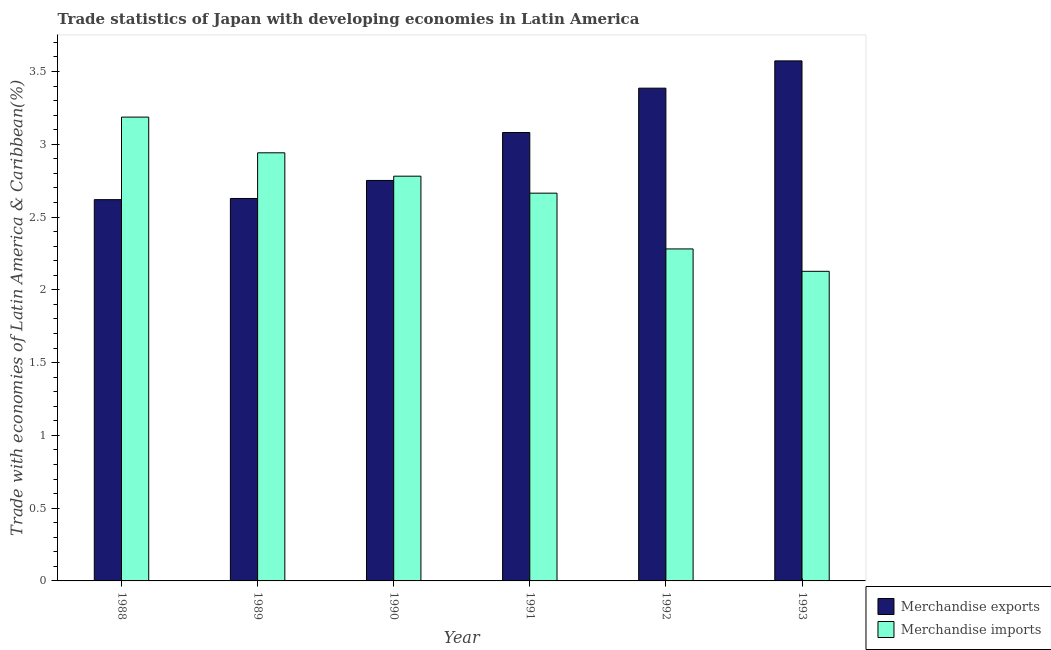How many different coloured bars are there?
Provide a succinct answer. 2. Are the number of bars on each tick of the X-axis equal?
Ensure brevity in your answer.  Yes. How many bars are there on the 2nd tick from the left?
Provide a succinct answer. 2. How many bars are there on the 4th tick from the right?
Offer a very short reply. 2. In how many cases, is the number of bars for a given year not equal to the number of legend labels?
Your answer should be compact. 0. What is the merchandise imports in 1989?
Provide a short and direct response. 2.94. Across all years, what is the maximum merchandise imports?
Keep it short and to the point. 3.19. Across all years, what is the minimum merchandise exports?
Your answer should be very brief. 2.62. In which year was the merchandise exports maximum?
Your response must be concise. 1993. What is the total merchandise imports in the graph?
Provide a short and direct response. 15.98. What is the difference between the merchandise exports in 1990 and that in 1993?
Your answer should be very brief. -0.82. What is the difference between the merchandise exports in 1990 and the merchandise imports in 1991?
Give a very brief answer. -0.33. What is the average merchandise imports per year?
Your answer should be compact. 2.66. In how many years, is the merchandise exports greater than 3.3 %?
Your answer should be compact. 2. What is the ratio of the merchandise exports in 1991 to that in 1993?
Your answer should be very brief. 0.86. Is the merchandise imports in 1990 less than that in 1992?
Make the answer very short. No. Is the difference between the merchandise exports in 1992 and 1993 greater than the difference between the merchandise imports in 1992 and 1993?
Keep it short and to the point. No. What is the difference between the highest and the second highest merchandise exports?
Your answer should be very brief. 0.19. What is the difference between the highest and the lowest merchandise imports?
Offer a terse response. 1.06. In how many years, is the merchandise imports greater than the average merchandise imports taken over all years?
Offer a very short reply. 4. What does the 1st bar from the left in 1992 represents?
Offer a very short reply. Merchandise exports. What does the 2nd bar from the right in 1988 represents?
Make the answer very short. Merchandise exports. How many years are there in the graph?
Make the answer very short. 6. What is the difference between two consecutive major ticks on the Y-axis?
Your answer should be compact. 0.5. Are the values on the major ticks of Y-axis written in scientific E-notation?
Ensure brevity in your answer.  No. Does the graph contain any zero values?
Your response must be concise. No. Where does the legend appear in the graph?
Your answer should be compact. Bottom right. What is the title of the graph?
Provide a short and direct response. Trade statistics of Japan with developing economies in Latin America. What is the label or title of the X-axis?
Provide a short and direct response. Year. What is the label or title of the Y-axis?
Your response must be concise. Trade with economies of Latin America & Caribbean(%). What is the Trade with economies of Latin America & Caribbean(%) in Merchandise exports in 1988?
Offer a terse response. 2.62. What is the Trade with economies of Latin America & Caribbean(%) in Merchandise imports in 1988?
Offer a very short reply. 3.19. What is the Trade with economies of Latin America & Caribbean(%) in Merchandise exports in 1989?
Keep it short and to the point. 2.63. What is the Trade with economies of Latin America & Caribbean(%) of Merchandise imports in 1989?
Your answer should be very brief. 2.94. What is the Trade with economies of Latin America & Caribbean(%) of Merchandise exports in 1990?
Your response must be concise. 2.75. What is the Trade with economies of Latin America & Caribbean(%) of Merchandise imports in 1990?
Offer a very short reply. 2.78. What is the Trade with economies of Latin America & Caribbean(%) in Merchandise exports in 1991?
Give a very brief answer. 3.08. What is the Trade with economies of Latin America & Caribbean(%) in Merchandise imports in 1991?
Provide a succinct answer. 2.66. What is the Trade with economies of Latin America & Caribbean(%) in Merchandise exports in 1992?
Make the answer very short. 3.39. What is the Trade with economies of Latin America & Caribbean(%) of Merchandise imports in 1992?
Your answer should be compact. 2.28. What is the Trade with economies of Latin America & Caribbean(%) in Merchandise exports in 1993?
Offer a very short reply. 3.57. What is the Trade with economies of Latin America & Caribbean(%) in Merchandise imports in 1993?
Give a very brief answer. 2.13. Across all years, what is the maximum Trade with economies of Latin America & Caribbean(%) of Merchandise exports?
Provide a short and direct response. 3.57. Across all years, what is the maximum Trade with economies of Latin America & Caribbean(%) in Merchandise imports?
Make the answer very short. 3.19. Across all years, what is the minimum Trade with economies of Latin America & Caribbean(%) of Merchandise exports?
Your response must be concise. 2.62. Across all years, what is the minimum Trade with economies of Latin America & Caribbean(%) in Merchandise imports?
Ensure brevity in your answer.  2.13. What is the total Trade with economies of Latin America & Caribbean(%) of Merchandise exports in the graph?
Offer a very short reply. 18.04. What is the total Trade with economies of Latin America & Caribbean(%) of Merchandise imports in the graph?
Ensure brevity in your answer.  15.98. What is the difference between the Trade with economies of Latin America & Caribbean(%) in Merchandise exports in 1988 and that in 1989?
Provide a short and direct response. -0.01. What is the difference between the Trade with economies of Latin America & Caribbean(%) in Merchandise imports in 1988 and that in 1989?
Provide a short and direct response. 0.25. What is the difference between the Trade with economies of Latin America & Caribbean(%) in Merchandise exports in 1988 and that in 1990?
Give a very brief answer. -0.13. What is the difference between the Trade with economies of Latin America & Caribbean(%) of Merchandise imports in 1988 and that in 1990?
Make the answer very short. 0.41. What is the difference between the Trade with economies of Latin America & Caribbean(%) of Merchandise exports in 1988 and that in 1991?
Provide a short and direct response. -0.46. What is the difference between the Trade with economies of Latin America & Caribbean(%) in Merchandise imports in 1988 and that in 1991?
Your response must be concise. 0.52. What is the difference between the Trade with economies of Latin America & Caribbean(%) in Merchandise exports in 1988 and that in 1992?
Ensure brevity in your answer.  -0.77. What is the difference between the Trade with economies of Latin America & Caribbean(%) in Merchandise imports in 1988 and that in 1992?
Ensure brevity in your answer.  0.91. What is the difference between the Trade with economies of Latin America & Caribbean(%) of Merchandise exports in 1988 and that in 1993?
Provide a succinct answer. -0.95. What is the difference between the Trade with economies of Latin America & Caribbean(%) in Merchandise imports in 1988 and that in 1993?
Make the answer very short. 1.06. What is the difference between the Trade with economies of Latin America & Caribbean(%) of Merchandise exports in 1989 and that in 1990?
Ensure brevity in your answer.  -0.12. What is the difference between the Trade with economies of Latin America & Caribbean(%) of Merchandise imports in 1989 and that in 1990?
Provide a short and direct response. 0.16. What is the difference between the Trade with economies of Latin America & Caribbean(%) of Merchandise exports in 1989 and that in 1991?
Provide a succinct answer. -0.45. What is the difference between the Trade with economies of Latin America & Caribbean(%) in Merchandise imports in 1989 and that in 1991?
Your answer should be very brief. 0.28. What is the difference between the Trade with economies of Latin America & Caribbean(%) in Merchandise exports in 1989 and that in 1992?
Provide a short and direct response. -0.76. What is the difference between the Trade with economies of Latin America & Caribbean(%) of Merchandise imports in 1989 and that in 1992?
Keep it short and to the point. 0.66. What is the difference between the Trade with economies of Latin America & Caribbean(%) in Merchandise exports in 1989 and that in 1993?
Your response must be concise. -0.95. What is the difference between the Trade with economies of Latin America & Caribbean(%) of Merchandise imports in 1989 and that in 1993?
Offer a very short reply. 0.81. What is the difference between the Trade with economies of Latin America & Caribbean(%) of Merchandise exports in 1990 and that in 1991?
Keep it short and to the point. -0.33. What is the difference between the Trade with economies of Latin America & Caribbean(%) of Merchandise imports in 1990 and that in 1991?
Give a very brief answer. 0.12. What is the difference between the Trade with economies of Latin America & Caribbean(%) of Merchandise exports in 1990 and that in 1992?
Provide a succinct answer. -0.63. What is the difference between the Trade with economies of Latin America & Caribbean(%) in Merchandise imports in 1990 and that in 1992?
Make the answer very short. 0.5. What is the difference between the Trade with economies of Latin America & Caribbean(%) in Merchandise exports in 1990 and that in 1993?
Your response must be concise. -0.82. What is the difference between the Trade with economies of Latin America & Caribbean(%) in Merchandise imports in 1990 and that in 1993?
Offer a very short reply. 0.65. What is the difference between the Trade with economies of Latin America & Caribbean(%) in Merchandise exports in 1991 and that in 1992?
Provide a succinct answer. -0.3. What is the difference between the Trade with economies of Latin America & Caribbean(%) of Merchandise imports in 1991 and that in 1992?
Provide a short and direct response. 0.38. What is the difference between the Trade with economies of Latin America & Caribbean(%) of Merchandise exports in 1991 and that in 1993?
Give a very brief answer. -0.49. What is the difference between the Trade with economies of Latin America & Caribbean(%) in Merchandise imports in 1991 and that in 1993?
Ensure brevity in your answer.  0.54. What is the difference between the Trade with economies of Latin America & Caribbean(%) in Merchandise exports in 1992 and that in 1993?
Give a very brief answer. -0.19. What is the difference between the Trade with economies of Latin America & Caribbean(%) of Merchandise imports in 1992 and that in 1993?
Your response must be concise. 0.15. What is the difference between the Trade with economies of Latin America & Caribbean(%) of Merchandise exports in 1988 and the Trade with economies of Latin America & Caribbean(%) of Merchandise imports in 1989?
Your response must be concise. -0.32. What is the difference between the Trade with economies of Latin America & Caribbean(%) of Merchandise exports in 1988 and the Trade with economies of Latin America & Caribbean(%) of Merchandise imports in 1990?
Offer a very short reply. -0.16. What is the difference between the Trade with economies of Latin America & Caribbean(%) of Merchandise exports in 1988 and the Trade with economies of Latin America & Caribbean(%) of Merchandise imports in 1991?
Provide a short and direct response. -0.04. What is the difference between the Trade with economies of Latin America & Caribbean(%) of Merchandise exports in 1988 and the Trade with economies of Latin America & Caribbean(%) of Merchandise imports in 1992?
Your response must be concise. 0.34. What is the difference between the Trade with economies of Latin America & Caribbean(%) in Merchandise exports in 1988 and the Trade with economies of Latin America & Caribbean(%) in Merchandise imports in 1993?
Provide a short and direct response. 0.49. What is the difference between the Trade with economies of Latin America & Caribbean(%) of Merchandise exports in 1989 and the Trade with economies of Latin America & Caribbean(%) of Merchandise imports in 1990?
Ensure brevity in your answer.  -0.15. What is the difference between the Trade with economies of Latin America & Caribbean(%) of Merchandise exports in 1989 and the Trade with economies of Latin America & Caribbean(%) of Merchandise imports in 1991?
Your answer should be very brief. -0.04. What is the difference between the Trade with economies of Latin America & Caribbean(%) in Merchandise exports in 1989 and the Trade with economies of Latin America & Caribbean(%) in Merchandise imports in 1992?
Your answer should be very brief. 0.35. What is the difference between the Trade with economies of Latin America & Caribbean(%) in Merchandise exports in 1989 and the Trade with economies of Latin America & Caribbean(%) in Merchandise imports in 1993?
Keep it short and to the point. 0.5. What is the difference between the Trade with economies of Latin America & Caribbean(%) of Merchandise exports in 1990 and the Trade with economies of Latin America & Caribbean(%) of Merchandise imports in 1991?
Your answer should be compact. 0.09. What is the difference between the Trade with economies of Latin America & Caribbean(%) in Merchandise exports in 1990 and the Trade with economies of Latin America & Caribbean(%) in Merchandise imports in 1992?
Offer a very short reply. 0.47. What is the difference between the Trade with economies of Latin America & Caribbean(%) of Merchandise exports in 1990 and the Trade with economies of Latin America & Caribbean(%) of Merchandise imports in 1993?
Provide a succinct answer. 0.62. What is the difference between the Trade with economies of Latin America & Caribbean(%) of Merchandise exports in 1991 and the Trade with economies of Latin America & Caribbean(%) of Merchandise imports in 1992?
Your response must be concise. 0.8. What is the difference between the Trade with economies of Latin America & Caribbean(%) in Merchandise exports in 1991 and the Trade with economies of Latin America & Caribbean(%) in Merchandise imports in 1993?
Ensure brevity in your answer.  0.95. What is the difference between the Trade with economies of Latin America & Caribbean(%) of Merchandise exports in 1992 and the Trade with economies of Latin America & Caribbean(%) of Merchandise imports in 1993?
Keep it short and to the point. 1.26. What is the average Trade with economies of Latin America & Caribbean(%) in Merchandise exports per year?
Provide a short and direct response. 3.01. What is the average Trade with economies of Latin America & Caribbean(%) of Merchandise imports per year?
Make the answer very short. 2.66. In the year 1988, what is the difference between the Trade with economies of Latin America & Caribbean(%) of Merchandise exports and Trade with economies of Latin America & Caribbean(%) of Merchandise imports?
Keep it short and to the point. -0.57. In the year 1989, what is the difference between the Trade with economies of Latin America & Caribbean(%) of Merchandise exports and Trade with economies of Latin America & Caribbean(%) of Merchandise imports?
Provide a succinct answer. -0.31. In the year 1990, what is the difference between the Trade with economies of Latin America & Caribbean(%) in Merchandise exports and Trade with economies of Latin America & Caribbean(%) in Merchandise imports?
Your answer should be compact. -0.03. In the year 1991, what is the difference between the Trade with economies of Latin America & Caribbean(%) of Merchandise exports and Trade with economies of Latin America & Caribbean(%) of Merchandise imports?
Your answer should be very brief. 0.42. In the year 1992, what is the difference between the Trade with economies of Latin America & Caribbean(%) of Merchandise exports and Trade with economies of Latin America & Caribbean(%) of Merchandise imports?
Your answer should be very brief. 1.1. In the year 1993, what is the difference between the Trade with economies of Latin America & Caribbean(%) in Merchandise exports and Trade with economies of Latin America & Caribbean(%) in Merchandise imports?
Make the answer very short. 1.45. What is the ratio of the Trade with economies of Latin America & Caribbean(%) of Merchandise imports in 1988 to that in 1989?
Make the answer very short. 1.08. What is the ratio of the Trade with economies of Latin America & Caribbean(%) of Merchandise exports in 1988 to that in 1990?
Ensure brevity in your answer.  0.95. What is the ratio of the Trade with economies of Latin America & Caribbean(%) of Merchandise imports in 1988 to that in 1990?
Your response must be concise. 1.15. What is the ratio of the Trade with economies of Latin America & Caribbean(%) of Merchandise exports in 1988 to that in 1991?
Make the answer very short. 0.85. What is the ratio of the Trade with economies of Latin America & Caribbean(%) in Merchandise imports in 1988 to that in 1991?
Give a very brief answer. 1.2. What is the ratio of the Trade with economies of Latin America & Caribbean(%) of Merchandise exports in 1988 to that in 1992?
Offer a terse response. 0.77. What is the ratio of the Trade with economies of Latin America & Caribbean(%) of Merchandise imports in 1988 to that in 1992?
Make the answer very short. 1.4. What is the ratio of the Trade with economies of Latin America & Caribbean(%) in Merchandise exports in 1988 to that in 1993?
Keep it short and to the point. 0.73. What is the ratio of the Trade with economies of Latin America & Caribbean(%) of Merchandise imports in 1988 to that in 1993?
Ensure brevity in your answer.  1.5. What is the ratio of the Trade with economies of Latin America & Caribbean(%) of Merchandise exports in 1989 to that in 1990?
Your answer should be compact. 0.95. What is the ratio of the Trade with economies of Latin America & Caribbean(%) in Merchandise imports in 1989 to that in 1990?
Your response must be concise. 1.06. What is the ratio of the Trade with economies of Latin America & Caribbean(%) in Merchandise exports in 1989 to that in 1991?
Keep it short and to the point. 0.85. What is the ratio of the Trade with economies of Latin America & Caribbean(%) in Merchandise imports in 1989 to that in 1991?
Provide a short and direct response. 1.1. What is the ratio of the Trade with economies of Latin America & Caribbean(%) in Merchandise exports in 1989 to that in 1992?
Offer a terse response. 0.78. What is the ratio of the Trade with economies of Latin America & Caribbean(%) in Merchandise imports in 1989 to that in 1992?
Keep it short and to the point. 1.29. What is the ratio of the Trade with economies of Latin America & Caribbean(%) of Merchandise exports in 1989 to that in 1993?
Ensure brevity in your answer.  0.74. What is the ratio of the Trade with economies of Latin America & Caribbean(%) of Merchandise imports in 1989 to that in 1993?
Your response must be concise. 1.38. What is the ratio of the Trade with economies of Latin America & Caribbean(%) in Merchandise exports in 1990 to that in 1991?
Offer a very short reply. 0.89. What is the ratio of the Trade with economies of Latin America & Caribbean(%) in Merchandise imports in 1990 to that in 1991?
Provide a short and direct response. 1.04. What is the ratio of the Trade with economies of Latin America & Caribbean(%) of Merchandise exports in 1990 to that in 1992?
Offer a terse response. 0.81. What is the ratio of the Trade with economies of Latin America & Caribbean(%) in Merchandise imports in 1990 to that in 1992?
Keep it short and to the point. 1.22. What is the ratio of the Trade with economies of Latin America & Caribbean(%) in Merchandise exports in 1990 to that in 1993?
Keep it short and to the point. 0.77. What is the ratio of the Trade with economies of Latin America & Caribbean(%) in Merchandise imports in 1990 to that in 1993?
Provide a succinct answer. 1.31. What is the ratio of the Trade with economies of Latin America & Caribbean(%) of Merchandise exports in 1991 to that in 1992?
Your response must be concise. 0.91. What is the ratio of the Trade with economies of Latin America & Caribbean(%) of Merchandise imports in 1991 to that in 1992?
Provide a short and direct response. 1.17. What is the ratio of the Trade with economies of Latin America & Caribbean(%) of Merchandise exports in 1991 to that in 1993?
Make the answer very short. 0.86. What is the ratio of the Trade with economies of Latin America & Caribbean(%) of Merchandise imports in 1991 to that in 1993?
Ensure brevity in your answer.  1.25. What is the ratio of the Trade with economies of Latin America & Caribbean(%) in Merchandise exports in 1992 to that in 1993?
Your response must be concise. 0.95. What is the ratio of the Trade with economies of Latin America & Caribbean(%) in Merchandise imports in 1992 to that in 1993?
Offer a terse response. 1.07. What is the difference between the highest and the second highest Trade with economies of Latin America & Caribbean(%) in Merchandise exports?
Provide a succinct answer. 0.19. What is the difference between the highest and the second highest Trade with economies of Latin America & Caribbean(%) in Merchandise imports?
Your answer should be compact. 0.25. What is the difference between the highest and the lowest Trade with economies of Latin America & Caribbean(%) of Merchandise exports?
Your answer should be very brief. 0.95. What is the difference between the highest and the lowest Trade with economies of Latin America & Caribbean(%) of Merchandise imports?
Give a very brief answer. 1.06. 